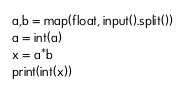<code> <loc_0><loc_0><loc_500><loc_500><_Python_>a,b = map(float, input().split())
a = int(a)
x = a*b
print(int(x))</code> 